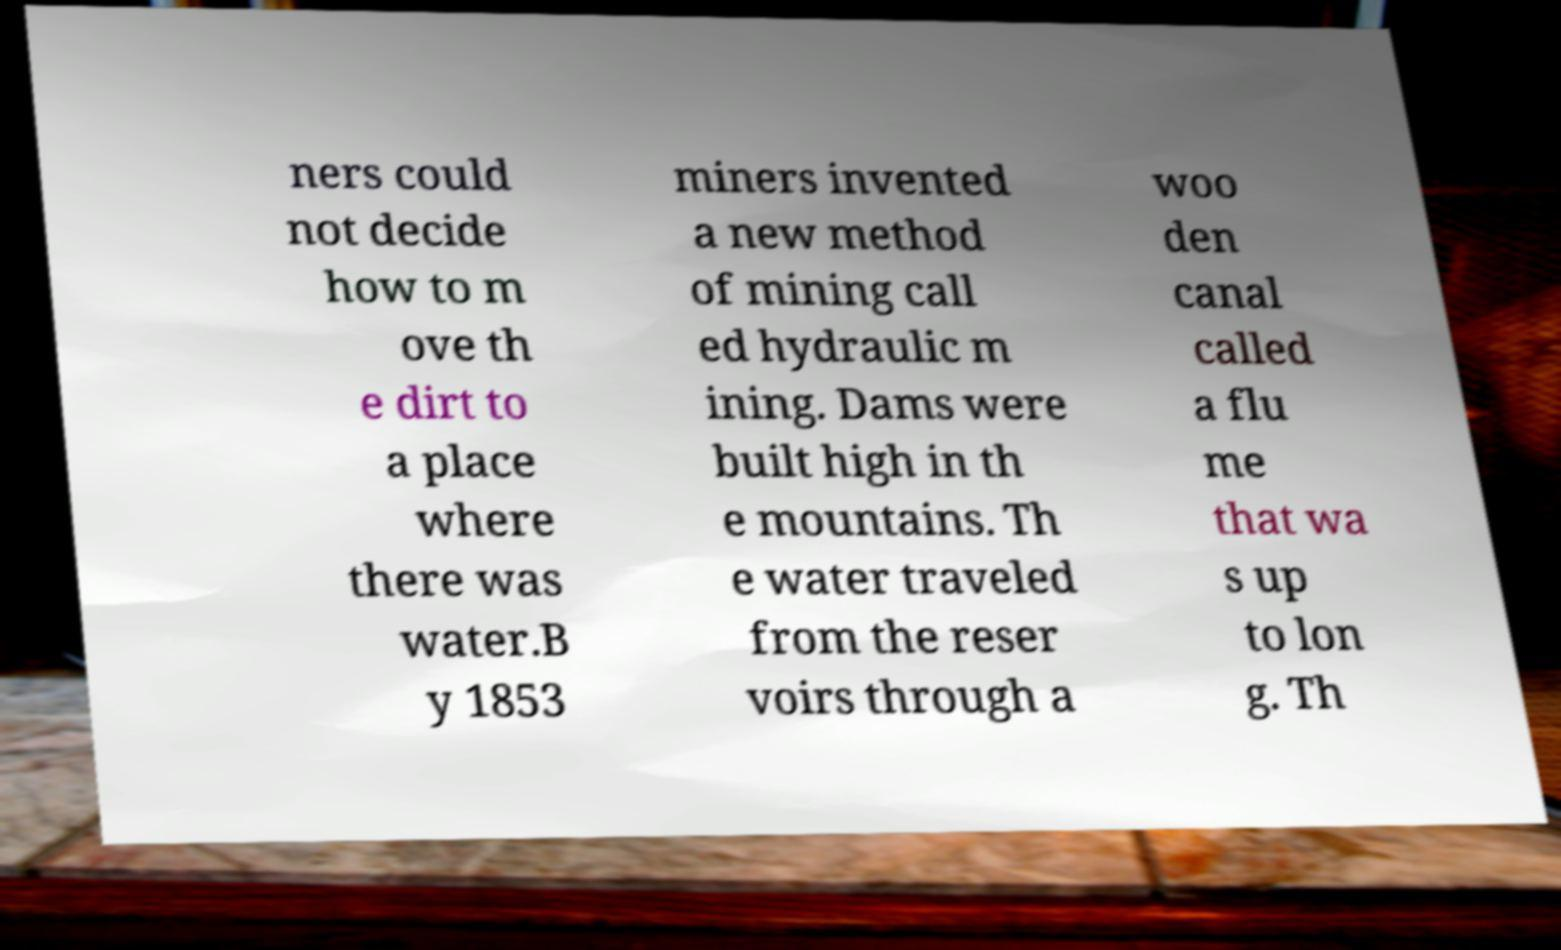Could you extract and type out the text from this image? ners could not decide how to m ove th e dirt to a place where there was water.B y 1853 miners invented a new method of mining call ed hydraulic m ining. Dams were built high in th e mountains. Th e water traveled from the reser voirs through a woo den canal called a flu me that wa s up to lon g. Th 